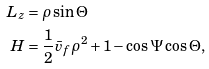<formula> <loc_0><loc_0><loc_500><loc_500>L _ { z } & = \rho \sin \Theta \\ H & = \frac { 1 } { 2 } \bar { v } _ { f } \rho ^ { 2 } + 1 - \cos \Psi \cos \Theta ,</formula> 